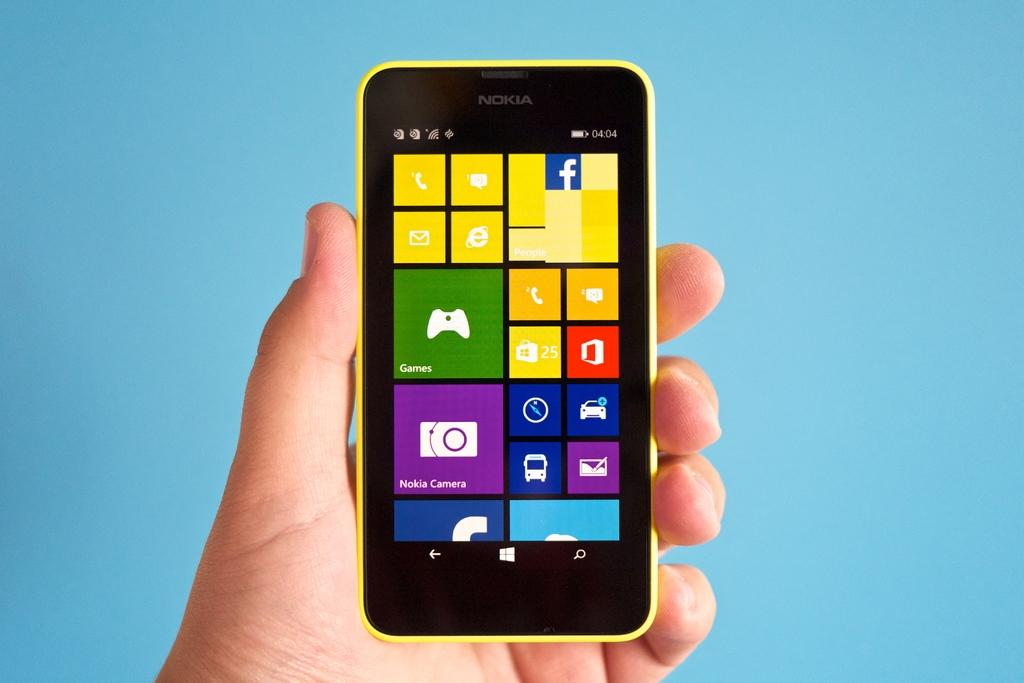Provide a one-sentence caption for the provided image. A person is holding a yellow phone that says Nokia. 